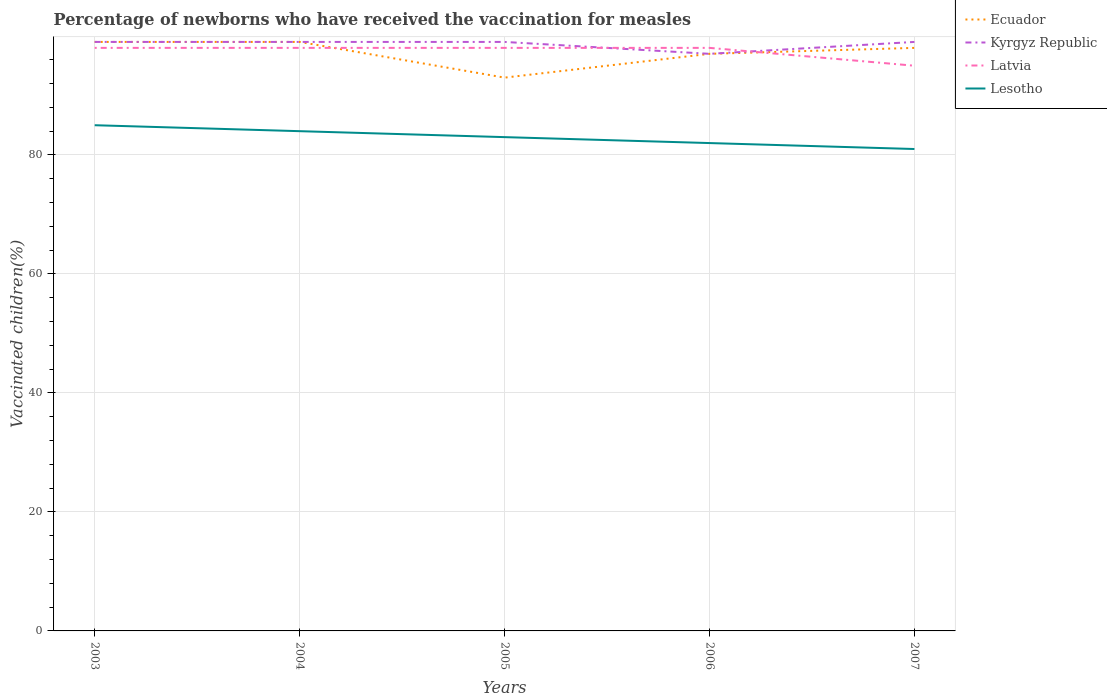Does the line corresponding to Latvia intersect with the line corresponding to Kyrgyz Republic?
Offer a terse response. Yes. Across all years, what is the maximum percentage of vaccinated children in Ecuador?
Give a very brief answer. 93. In which year was the percentage of vaccinated children in Latvia maximum?
Provide a short and direct response. 2007. What is the total percentage of vaccinated children in Ecuador in the graph?
Your response must be concise. -4. What is the difference between the highest and the second highest percentage of vaccinated children in Ecuador?
Offer a very short reply. 6. What is the difference between the highest and the lowest percentage of vaccinated children in Ecuador?
Provide a succinct answer. 3. What is the difference between two consecutive major ticks on the Y-axis?
Ensure brevity in your answer.  20. Does the graph contain any zero values?
Provide a succinct answer. No. How many legend labels are there?
Give a very brief answer. 4. What is the title of the graph?
Your response must be concise. Percentage of newborns who have received the vaccination for measles. What is the label or title of the Y-axis?
Provide a short and direct response. Vaccinated children(%). What is the Vaccinated children(%) in Lesotho in 2003?
Make the answer very short. 85. What is the Vaccinated children(%) of Ecuador in 2004?
Your answer should be very brief. 99. What is the Vaccinated children(%) in Lesotho in 2004?
Provide a short and direct response. 84. What is the Vaccinated children(%) of Ecuador in 2005?
Provide a succinct answer. 93. What is the Vaccinated children(%) in Ecuador in 2006?
Your response must be concise. 97. What is the Vaccinated children(%) of Kyrgyz Republic in 2006?
Offer a terse response. 97. What is the Vaccinated children(%) of Ecuador in 2007?
Ensure brevity in your answer.  98. What is the Vaccinated children(%) in Kyrgyz Republic in 2007?
Give a very brief answer. 99. Across all years, what is the maximum Vaccinated children(%) of Ecuador?
Make the answer very short. 99. Across all years, what is the maximum Vaccinated children(%) of Kyrgyz Republic?
Give a very brief answer. 99. Across all years, what is the minimum Vaccinated children(%) in Ecuador?
Keep it short and to the point. 93. Across all years, what is the minimum Vaccinated children(%) of Kyrgyz Republic?
Provide a short and direct response. 97. Across all years, what is the minimum Vaccinated children(%) of Latvia?
Give a very brief answer. 95. What is the total Vaccinated children(%) of Ecuador in the graph?
Keep it short and to the point. 486. What is the total Vaccinated children(%) of Kyrgyz Republic in the graph?
Give a very brief answer. 493. What is the total Vaccinated children(%) of Latvia in the graph?
Offer a very short reply. 487. What is the total Vaccinated children(%) of Lesotho in the graph?
Keep it short and to the point. 415. What is the difference between the Vaccinated children(%) in Kyrgyz Republic in 2003 and that in 2004?
Provide a succinct answer. 0. What is the difference between the Vaccinated children(%) in Lesotho in 2003 and that in 2005?
Offer a very short reply. 2. What is the difference between the Vaccinated children(%) of Ecuador in 2003 and that in 2006?
Offer a terse response. 2. What is the difference between the Vaccinated children(%) in Latvia in 2003 and that in 2006?
Your answer should be very brief. 0. What is the difference between the Vaccinated children(%) in Ecuador in 2003 and that in 2007?
Keep it short and to the point. 1. What is the difference between the Vaccinated children(%) of Kyrgyz Republic in 2003 and that in 2007?
Your answer should be compact. 0. What is the difference between the Vaccinated children(%) in Ecuador in 2004 and that in 2005?
Your answer should be compact. 6. What is the difference between the Vaccinated children(%) in Latvia in 2004 and that in 2005?
Your response must be concise. 0. What is the difference between the Vaccinated children(%) in Lesotho in 2004 and that in 2005?
Provide a succinct answer. 1. What is the difference between the Vaccinated children(%) in Ecuador in 2004 and that in 2006?
Your response must be concise. 2. What is the difference between the Vaccinated children(%) of Lesotho in 2004 and that in 2006?
Your response must be concise. 2. What is the difference between the Vaccinated children(%) in Ecuador in 2004 and that in 2007?
Provide a succinct answer. 1. What is the difference between the Vaccinated children(%) in Latvia in 2004 and that in 2007?
Your answer should be very brief. 3. What is the difference between the Vaccinated children(%) in Ecuador in 2005 and that in 2006?
Keep it short and to the point. -4. What is the difference between the Vaccinated children(%) in Kyrgyz Republic in 2005 and that in 2006?
Make the answer very short. 2. What is the difference between the Vaccinated children(%) in Lesotho in 2005 and that in 2006?
Offer a very short reply. 1. What is the difference between the Vaccinated children(%) in Ecuador in 2005 and that in 2007?
Your answer should be very brief. -5. What is the difference between the Vaccinated children(%) in Kyrgyz Republic in 2006 and that in 2007?
Give a very brief answer. -2. What is the difference between the Vaccinated children(%) in Latvia in 2006 and that in 2007?
Keep it short and to the point. 3. What is the difference between the Vaccinated children(%) in Lesotho in 2006 and that in 2007?
Provide a succinct answer. 1. What is the difference between the Vaccinated children(%) in Ecuador in 2003 and the Vaccinated children(%) in Kyrgyz Republic in 2004?
Provide a short and direct response. 0. What is the difference between the Vaccinated children(%) of Kyrgyz Republic in 2003 and the Vaccinated children(%) of Lesotho in 2004?
Offer a very short reply. 15. What is the difference between the Vaccinated children(%) in Latvia in 2003 and the Vaccinated children(%) in Lesotho in 2004?
Make the answer very short. 14. What is the difference between the Vaccinated children(%) of Ecuador in 2003 and the Vaccinated children(%) of Kyrgyz Republic in 2005?
Keep it short and to the point. 0. What is the difference between the Vaccinated children(%) in Ecuador in 2003 and the Vaccinated children(%) in Latvia in 2005?
Your answer should be compact. 1. What is the difference between the Vaccinated children(%) of Ecuador in 2003 and the Vaccinated children(%) of Lesotho in 2005?
Your answer should be compact. 16. What is the difference between the Vaccinated children(%) in Ecuador in 2003 and the Vaccinated children(%) in Kyrgyz Republic in 2006?
Offer a very short reply. 2. What is the difference between the Vaccinated children(%) in Ecuador in 2003 and the Vaccinated children(%) in Latvia in 2006?
Make the answer very short. 1. What is the difference between the Vaccinated children(%) in Ecuador in 2003 and the Vaccinated children(%) in Lesotho in 2007?
Provide a succinct answer. 18. What is the difference between the Vaccinated children(%) of Kyrgyz Republic in 2003 and the Vaccinated children(%) of Latvia in 2007?
Keep it short and to the point. 4. What is the difference between the Vaccinated children(%) of Ecuador in 2004 and the Vaccinated children(%) of Kyrgyz Republic in 2005?
Your answer should be very brief. 0. What is the difference between the Vaccinated children(%) in Ecuador in 2004 and the Vaccinated children(%) in Latvia in 2005?
Give a very brief answer. 1. What is the difference between the Vaccinated children(%) in Ecuador in 2004 and the Vaccinated children(%) in Lesotho in 2005?
Give a very brief answer. 16. What is the difference between the Vaccinated children(%) in Kyrgyz Republic in 2004 and the Vaccinated children(%) in Latvia in 2005?
Make the answer very short. 1. What is the difference between the Vaccinated children(%) of Ecuador in 2004 and the Vaccinated children(%) of Kyrgyz Republic in 2006?
Your answer should be compact. 2. What is the difference between the Vaccinated children(%) in Ecuador in 2004 and the Vaccinated children(%) in Latvia in 2006?
Provide a succinct answer. 1. What is the difference between the Vaccinated children(%) of Ecuador in 2004 and the Vaccinated children(%) of Lesotho in 2006?
Provide a short and direct response. 17. What is the difference between the Vaccinated children(%) in Kyrgyz Republic in 2004 and the Vaccinated children(%) in Lesotho in 2006?
Your response must be concise. 17. What is the difference between the Vaccinated children(%) of Latvia in 2004 and the Vaccinated children(%) of Lesotho in 2006?
Provide a succinct answer. 16. What is the difference between the Vaccinated children(%) in Ecuador in 2004 and the Vaccinated children(%) in Kyrgyz Republic in 2007?
Provide a short and direct response. 0. What is the difference between the Vaccinated children(%) of Ecuador in 2004 and the Vaccinated children(%) of Latvia in 2007?
Offer a terse response. 4. What is the difference between the Vaccinated children(%) in Ecuador in 2004 and the Vaccinated children(%) in Lesotho in 2007?
Give a very brief answer. 18. What is the difference between the Vaccinated children(%) of Kyrgyz Republic in 2004 and the Vaccinated children(%) of Latvia in 2007?
Ensure brevity in your answer.  4. What is the difference between the Vaccinated children(%) in Kyrgyz Republic in 2004 and the Vaccinated children(%) in Lesotho in 2007?
Ensure brevity in your answer.  18. What is the difference between the Vaccinated children(%) of Kyrgyz Republic in 2005 and the Vaccinated children(%) of Latvia in 2006?
Your response must be concise. 1. What is the difference between the Vaccinated children(%) in Kyrgyz Republic in 2005 and the Vaccinated children(%) in Lesotho in 2006?
Your answer should be very brief. 17. What is the difference between the Vaccinated children(%) of Latvia in 2005 and the Vaccinated children(%) of Lesotho in 2006?
Your response must be concise. 16. What is the difference between the Vaccinated children(%) in Ecuador in 2005 and the Vaccinated children(%) in Kyrgyz Republic in 2007?
Provide a succinct answer. -6. What is the difference between the Vaccinated children(%) in Kyrgyz Republic in 2005 and the Vaccinated children(%) in Lesotho in 2007?
Make the answer very short. 18. What is the difference between the Vaccinated children(%) in Kyrgyz Republic in 2006 and the Vaccinated children(%) in Latvia in 2007?
Ensure brevity in your answer.  2. What is the difference between the Vaccinated children(%) in Kyrgyz Republic in 2006 and the Vaccinated children(%) in Lesotho in 2007?
Make the answer very short. 16. What is the difference between the Vaccinated children(%) in Latvia in 2006 and the Vaccinated children(%) in Lesotho in 2007?
Your answer should be compact. 17. What is the average Vaccinated children(%) of Ecuador per year?
Provide a short and direct response. 97.2. What is the average Vaccinated children(%) of Kyrgyz Republic per year?
Offer a terse response. 98.6. What is the average Vaccinated children(%) of Latvia per year?
Provide a succinct answer. 97.4. In the year 2003, what is the difference between the Vaccinated children(%) of Ecuador and Vaccinated children(%) of Kyrgyz Republic?
Give a very brief answer. 0. In the year 2003, what is the difference between the Vaccinated children(%) in Kyrgyz Republic and Vaccinated children(%) in Latvia?
Your response must be concise. 1. In the year 2003, what is the difference between the Vaccinated children(%) of Latvia and Vaccinated children(%) of Lesotho?
Offer a very short reply. 13. In the year 2004, what is the difference between the Vaccinated children(%) in Ecuador and Vaccinated children(%) in Kyrgyz Republic?
Your response must be concise. 0. In the year 2004, what is the difference between the Vaccinated children(%) of Ecuador and Vaccinated children(%) of Lesotho?
Make the answer very short. 15. In the year 2004, what is the difference between the Vaccinated children(%) of Kyrgyz Republic and Vaccinated children(%) of Lesotho?
Provide a succinct answer. 15. In the year 2004, what is the difference between the Vaccinated children(%) in Latvia and Vaccinated children(%) in Lesotho?
Give a very brief answer. 14. In the year 2005, what is the difference between the Vaccinated children(%) of Ecuador and Vaccinated children(%) of Kyrgyz Republic?
Your response must be concise. -6. In the year 2006, what is the difference between the Vaccinated children(%) in Ecuador and Vaccinated children(%) in Latvia?
Provide a succinct answer. -1. In the year 2006, what is the difference between the Vaccinated children(%) of Ecuador and Vaccinated children(%) of Lesotho?
Ensure brevity in your answer.  15. In the year 2006, what is the difference between the Vaccinated children(%) of Kyrgyz Republic and Vaccinated children(%) of Latvia?
Your answer should be compact. -1. In the year 2006, what is the difference between the Vaccinated children(%) in Kyrgyz Republic and Vaccinated children(%) in Lesotho?
Keep it short and to the point. 15. In the year 2006, what is the difference between the Vaccinated children(%) of Latvia and Vaccinated children(%) of Lesotho?
Your response must be concise. 16. In the year 2007, what is the difference between the Vaccinated children(%) in Latvia and Vaccinated children(%) in Lesotho?
Keep it short and to the point. 14. What is the ratio of the Vaccinated children(%) of Kyrgyz Republic in 2003 to that in 2004?
Make the answer very short. 1. What is the ratio of the Vaccinated children(%) of Latvia in 2003 to that in 2004?
Your answer should be compact. 1. What is the ratio of the Vaccinated children(%) in Lesotho in 2003 to that in 2004?
Give a very brief answer. 1.01. What is the ratio of the Vaccinated children(%) in Ecuador in 2003 to that in 2005?
Give a very brief answer. 1.06. What is the ratio of the Vaccinated children(%) in Kyrgyz Republic in 2003 to that in 2005?
Provide a short and direct response. 1. What is the ratio of the Vaccinated children(%) of Lesotho in 2003 to that in 2005?
Offer a very short reply. 1.02. What is the ratio of the Vaccinated children(%) of Ecuador in 2003 to that in 2006?
Make the answer very short. 1.02. What is the ratio of the Vaccinated children(%) of Kyrgyz Republic in 2003 to that in 2006?
Your answer should be compact. 1.02. What is the ratio of the Vaccinated children(%) in Latvia in 2003 to that in 2006?
Provide a short and direct response. 1. What is the ratio of the Vaccinated children(%) of Lesotho in 2003 to that in 2006?
Your answer should be compact. 1.04. What is the ratio of the Vaccinated children(%) of Ecuador in 2003 to that in 2007?
Ensure brevity in your answer.  1.01. What is the ratio of the Vaccinated children(%) in Kyrgyz Republic in 2003 to that in 2007?
Ensure brevity in your answer.  1. What is the ratio of the Vaccinated children(%) in Latvia in 2003 to that in 2007?
Provide a succinct answer. 1.03. What is the ratio of the Vaccinated children(%) of Lesotho in 2003 to that in 2007?
Provide a short and direct response. 1.05. What is the ratio of the Vaccinated children(%) of Ecuador in 2004 to that in 2005?
Provide a short and direct response. 1.06. What is the ratio of the Vaccinated children(%) in Kyrgyz Republic in 2004 to that in 2005?
Keep it short and to the point. 1. What is the ratio of the Vaccinated children(%) of Latvia in 2004 to that in 2005?
Make the answer very short. 1. What is the ratio of the Vaccinated children(%) in Lesotho in 2004 to that in 2005?
Give a very brief answer. 1.01. What is the ratio of the Vaccinated children(%) of Ecuador in 2004 to that in 2006?
Your answer should be very brief. 1.02. What is the ratio of the Vaccinated children(%) of Kyrgyz Republic in 2004 to that in 2006?
Provide a succinct answer. 1.02. What is the ratio of the Vaccinated children(%) of Latvia in 2004 to that in 2006?
Your response must be concise. 1. What is the ratio of the Vaccinated children(%) in Lesotho in 2004 to that in 2006?
Offer a terse response. 1.02. What is the ratio of the Vaccinated children(%) in Ecuador in 2004 to that in 2007?
Keep it short and to the point. 1.01. What is the ratio of the Vaccinated children(%) of Kyrgyz Republic in 2004 to that in 2007?
Provide a short and direct response. 1. What is the ratio of the Vaccinated children(%) in Latvia in 2004 to that in 2007?
Your answer should be compact. 1.03. What is the ratio of the Vaccinated children(%) in Ecuador in 2005 to that in 2006?
Keep it short and to the point. 0.96. What is the ratio of the Vaccinated children(%) of Kyrgyz Republic in 2005 to that in 2006?
Offer a very short reply. 1.02. What is the ratio of the Vaccinated children(%) of Lesotho in 2005 to that in 2006?
Provide a succinct answer. 1.01. What is the ratio of the Vaccinated children(%) of Ecuador in 2005 to that in 2007?
Make the answer very short. 0.95. What is the ratio of the Vaccinated children(%) of Kyrgyz Republic in 2005 to that in 2007?
Your response must be concise. 1. What is the ratio of the Vaccinated children(%) in Latvia in 2005 to that in 2007?
Keep it short and to the point. 1.03. What is the ratio of the Vaccinated children(%) in Lesotho in 2005 to that in 2007?
Provide a succinct answer. 1.02. What is the ratio of the Vaccinated children(%) in Kyrgyz Republic in 2006 to that in 2007?
Your response must be concise. 0.98. What is the ratio of the Vaccinated children(%) of Latvia in 2006 to that in 2007?
Give a very brief answer. 1.03. What is the ratio of the Vaccinated children(%) of Lesotho in 2006 to that in 2007?
Keep it short and to the point. 1.01. What is the difference between the highest and the second highest Vaccinated children(%) of Ecuador?
Offer a very short reply. 0. What is the difference between the highest and the second highest Vaccinated children(%) of Latvia?
Your answer should be compact. 0. What is the difference between the highest and the lowest Vaccinated children(%) of Ecuador?
Provide a short and direct response. 6. What is the difference between the highest and the lowest Vaccinated children(%) in Latvia?
Your answer should be very brief. 3. 